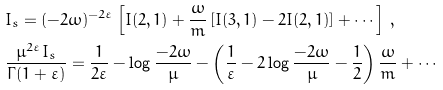Convert formula to latex. <formula><loc_0><loc_0><loc_500><loc_500>& I _ { s } = ( - 2 \omega ) ^ { - 2 \varepsilon } \left [ I ( 2 , 1 ) + \frac { \omega } { m } \left [ I ( 3 , 1 ) - 2 I ( 2 , 1 ) \right ] + \cdots \right ] \, , \\ & \frac { \mu ^ { 2 \varepsilon } I _ { s } } { \Gamma ( 1 + \varepsilon ) } = \frac { 1 } { 2 \varepsilon } - \log \frac { - 2 \omega } { \mu } - \left ( \frac { 1 } { \varepsilon } - 2 \log \frac { - 2 \omega } { \mu } - \frac { 1 } { 2 } \right ) \frac { \omega } { m } + \cdots</formula> 